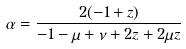<formula> <loc_0><loc_0><loc_500><loc_500>\alpha = \frac { 2 ( - 1 + z ) } { - 1 - \mu + \nu + 2 z + 2 \mu z }</formula> 